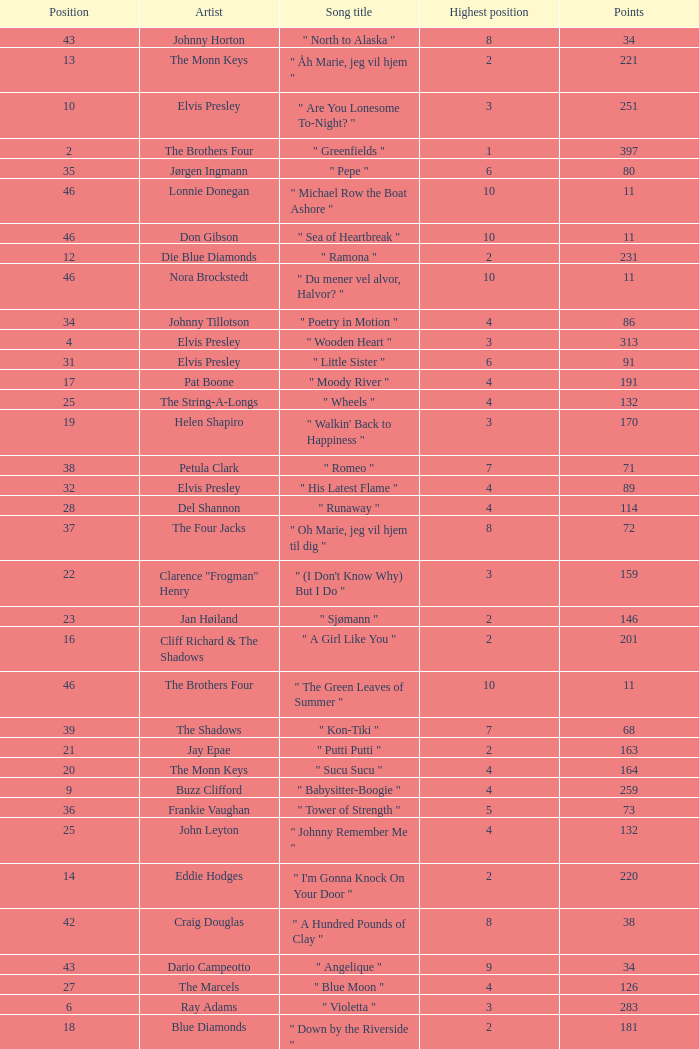What is the title of the song that received 259 points? " Babysitter-Boogie ". 